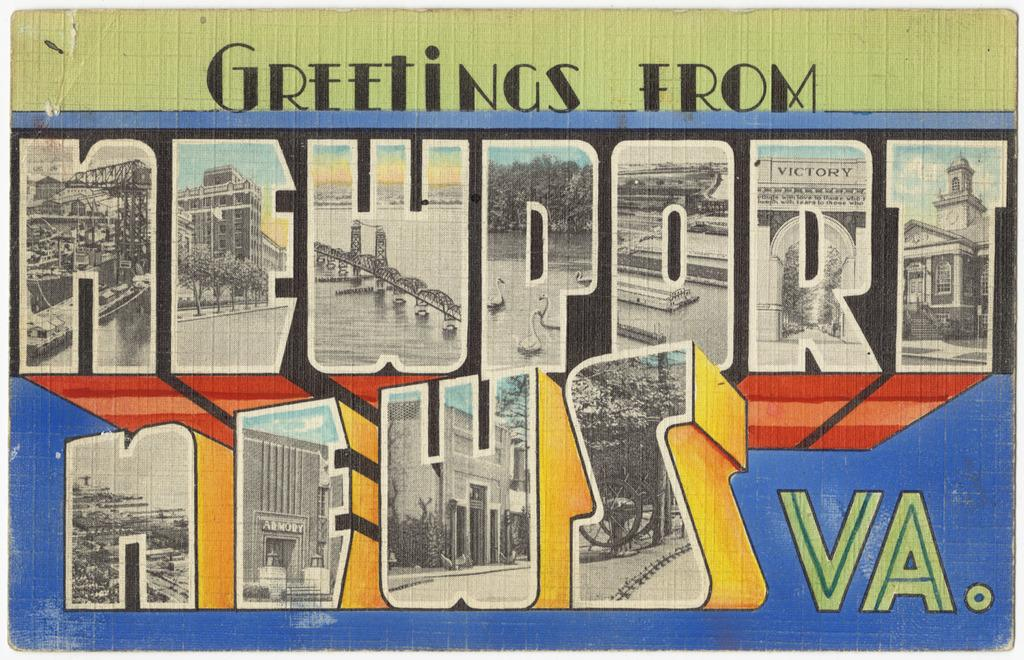<image>
Provide a brief description of the given image. Postcard saying: Greetings from Newport News VA, that is labeled in different colors. 